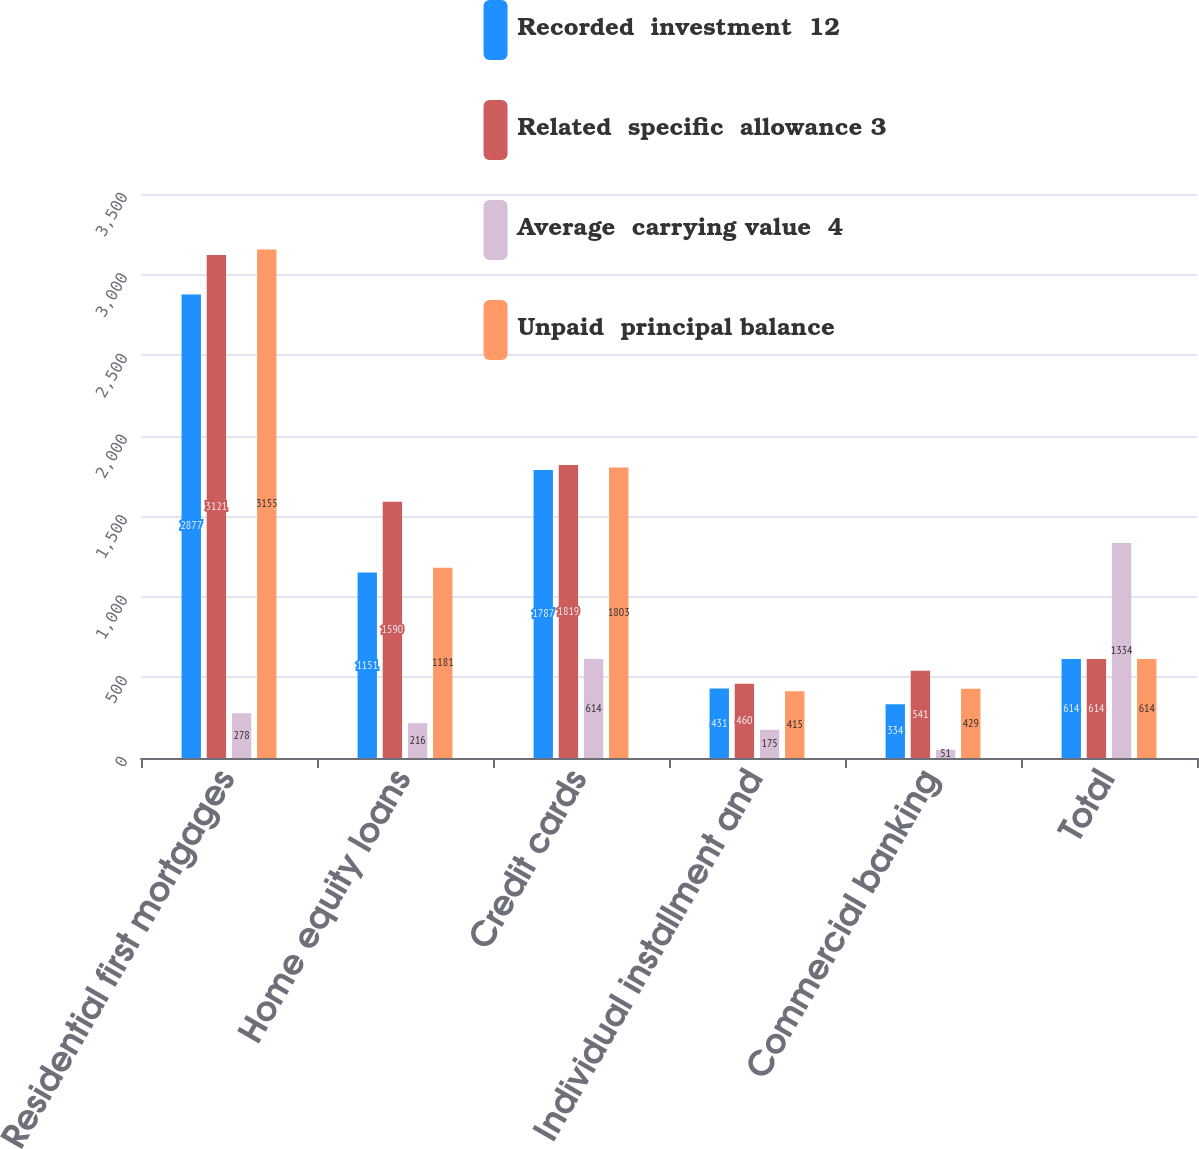Convert chart to OTSL. <chart><loc_0><loc_0><loc_500><loc_500><stacked_bar_chart><ecel><fcel>Residential first mortgages<fcel>Home equity loans<fcel>Credit cards<fcel>Individual installment and<fcel>Commercial banking<fcel>Total<nl><fcel>Recorded  investment  12<fcel>2877<fcel>1151<fcel>1787<fcel>431<fcel>334<fcel>614<nl><fcel>Related  specific  allowance 3<fcel>3121<fcel>1590<fcel>1819<fcel>460<fcel>541<fcel>614<nl><fcel>Average  carrying value  4<fcel>278<fcel>216<fcel>614<fcel>175<fcel>51<fcel>1334<nl><fcel>Unpaid  principal balance<fcel>3155<fcel>1181<fcel>1803<fcel>415<fcel>429<fcel>614<nl></chart> 